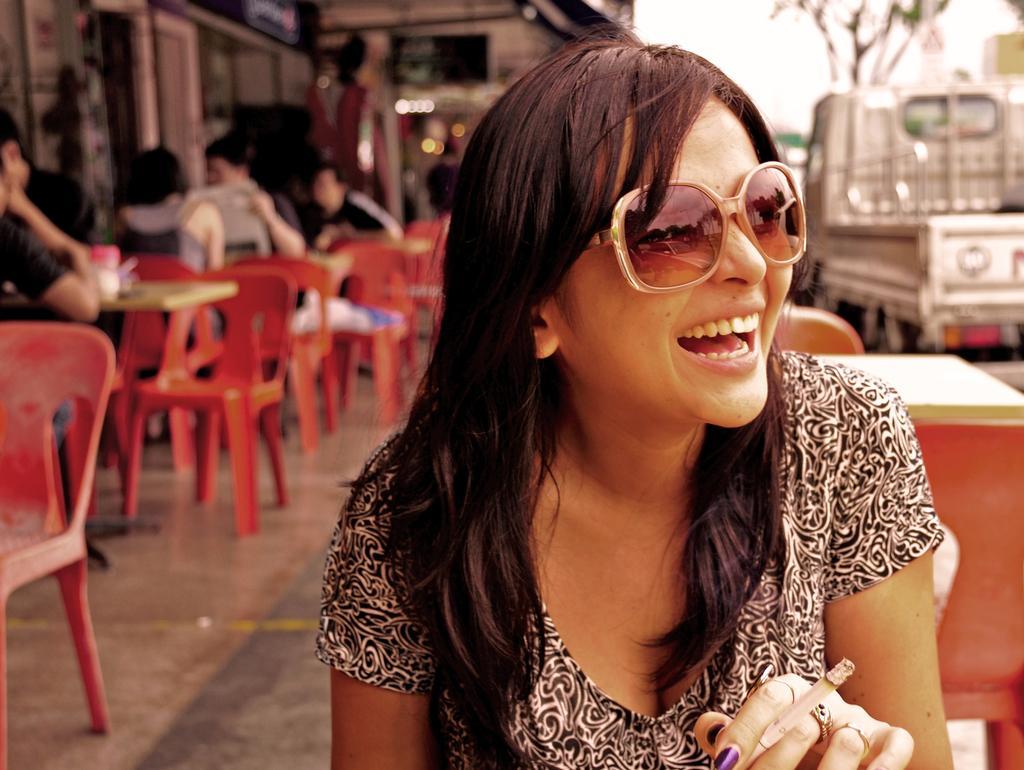Can you describe this image briefly? In this image I see a woman who is smiling and sitting. In the background I can see lot of chairs, tables, few people, a building and a vehicle. 